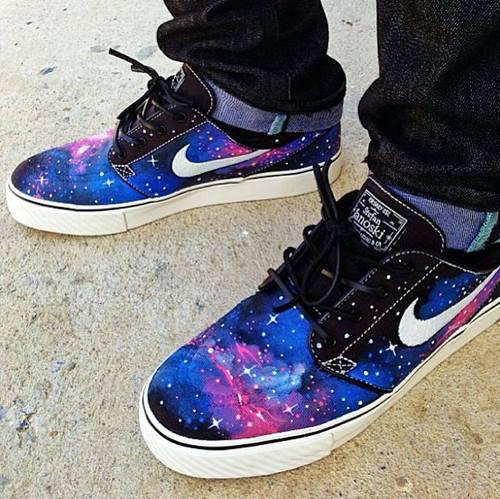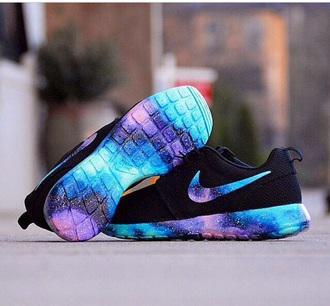The first image is the image on the left, the second image is the image on the right. Examine the images to the left and right. Is the description "One pair of casual shoes has a small black tag sticking up from the back of each shoe." accurate? Answer yes or no. Yes. 